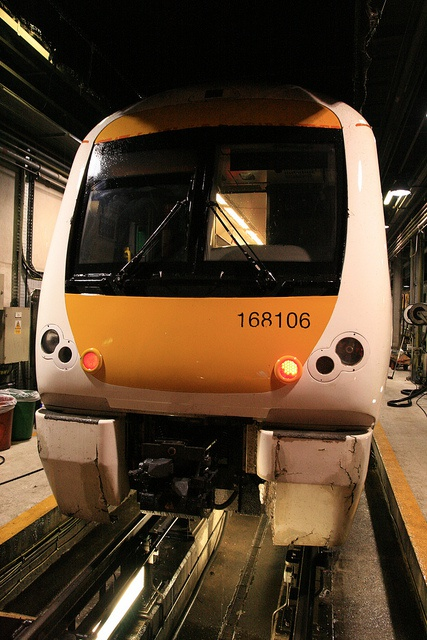Describe the objects in this image and their specific colors. I can see a train in black, orange, ivory, and maroon tones in this image. 